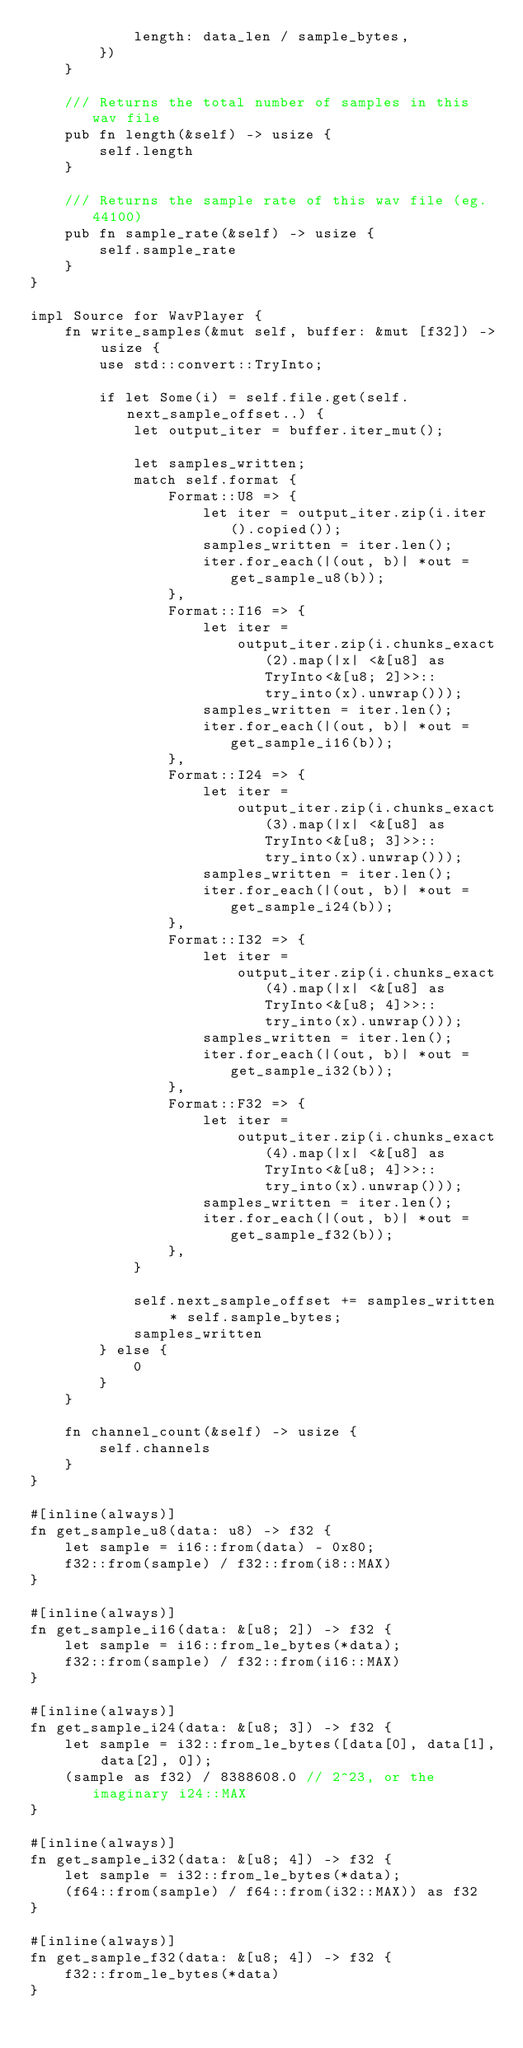<code> <loc_0><loc_0><loc_500><loc_500><_Rust_>            length: data_len / sample_bytes,
        })
    }

    /// Returns the total number of samples in this wav file
    pub fn length(&self) -> usize {
        self.length
    }

    /// Returns the sample rate of this wav file (eg. 44100)
    pub fn sample_rate(&self) -> usize {
        self.sample_rate
    }
}

impl Source for WavPlayer {
    fn write_samples(&mut self, buffer: &mut [f32]) -> usize {
        use std::convert::TryInto;

        if let Some(i) = self.file.get(self.next_sample_offset..) {
            let output_iter = buffer.iter_mut();

            let samples_written;
            match self.format {
                Format::U8 => {
                    let iter = output_iter.zip(i.iter().copied());
                    samples_written = iter.len();
                    iter.for_each(|(out, b)| *out = get_sample_u8(b));
                },
                Format::I16 => {
                    let iter =
                        output_iter.zip(i.chunks_exact(2).map(|x| <&[u8] as TryInto<&[u8; 2]>>::try_into(x).unwrap()));
                    samples_written = iter.len();
                    iter.for_each(|(out, b)| *out = get_sample_i16(b));
                },
                Format::I24 => {
                    let iter =
                        output_iter.zip(i.chunks_exact(3).map(|x| <&[u8] as TryInto<&[u8; 3]>>::try_into(x).unwrap()));
                    samples_written = iter.len();
                    iter.for_each(|(out, b)| *out = get_sample_i24(b));
                },
                Format::I32 => {
                    let iter =
                        output_iter.zip(i.chunks_exact(4).map(|x| <&[u8] as TryInto<&[u8; 4]>>::try_into(x).unwrap()));
                    samples_written = iter.len();
                    iter.for_each(|(out, b)| *out = get_sample_i32(b));
                },
                Format::F32 => {
                    let iter =
                        output_iter.zip(i.chunks_exact(4).map(|x| <&[u8] as TryInto<&[u8; 4]>>::try_into(x).unwrap()));
                    samples_written = iter.len();
                    iter.for_each(|(out, b)| *out = get_sample_f32(b));
                },
            }

            self.next_sample_offset += samples_written * self.sample_bytes;
            samples_written
        } else {
            0
        }
    }

    fn channel_count(&self) -> usize {
        self.channels
    }
}

#[inline(always)]
fn get_sample_u8(data: u8) -> f32 {
    let sample = i16::from(data) - 0x80;
    f32::from(sample) / f32::from(i8::MAX)
}

#[inline(always)]
fn get_sample_i16(data: &[u8; 2]) -> f32 {
    let sample = i16::from_le_bytes(*data);
    f32::from(sample) / f32::from(i16::MAX)
}

#[inline(always)]
fn get_sample_i24(data: &[u8; 3]) -> f32 {
    let sample = i32::from_le_bytes([data[0], data[1], data[2], 0]);
    (sample as f32) / 8388608.0 // 2^23, or the imaginary i24::MAX
}

#[inline(always)]
fn get_sample_i32(data: &[u8; 4]) -> f32 {
    let sample = i32::from_le_bytes(*data);
    (f64::from(sample) / f64::from(i32::MAX)) as f32
}

#[inline(always)]
fn get_sample_f32(data: &[u8; 4]) -> f32 {
    f32::from_le_bytes(*data)
}
</code> 